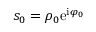<formula> <loc_0><loc_0><loc_500><loc_500>s _ { 0 } = \rho _ { 0 } e ^ { i \varphi _ { 0 } }</formula> 